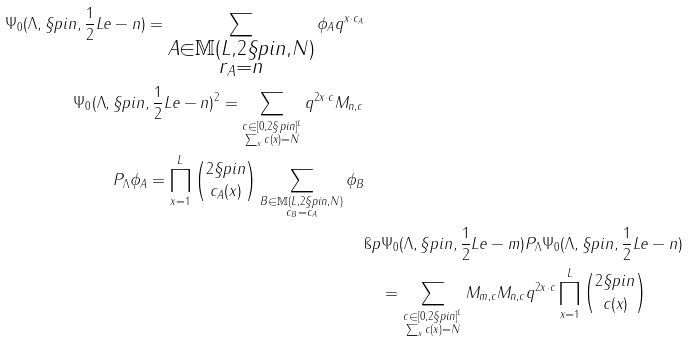<formula> <loc_0><loc_0><loc_500><loc_500>\Psi _ { 0 } ( \Lambda , \S p i n , \frac { 1 } { 2 } L e - n ) = \sum _ { \substack { A \in \mathbb { M } ( L , 2 \S p i n , N ) \\ r _ { A } = n } } \phi _ { A } q ^ { x \cdot c _ { A } } \\ \| \Psi _ { 0 } ( \Lambda , \S p i n , \frac { 1 } { 2 } L e - n ) \| ^ { 2 } = \sum _ { \substack { c \in [ 0 , 2 \S p i n ] ^ { L } \\ \sum _ { x } c ( x ) = N } } q ^ { 2 x \cdot c } M _ { n , c } \\ P _ { \Lambda } \phi _ { A } = \prod _ { x = 1 } ^ { L } \binom { 2 \S p i n } { c _ { A } ( x ) } \sum _ { \substack { B \in \mathbb { M } ( L , 2 \S p i n , N ) \\ c _ { B } = c _ { A } } } \phi _ { B } \\ & \i p { \Psi _ { 0 } ( \Lambda , \S p i n , \frac { 1 } { 2 } L e - m ) } { P _ { \Lambda } \Psi _ { 0 } ( \Lambda , \S p i n , \frac { 1 } { 2 } L e - n ) } \\ & \quad = \sum _ { \substack { c \in [ 0 , 2 \S p i n ] ^ { L } \\ \sum _ { x } c ( x ) = N } } M _ { m , c } M _ { n , c } q ^ { 2 x \cdot c } \prod _ { x = 1 } ^ { L } \binom { 2 \S p i n } { c ( x ) }</formula> 